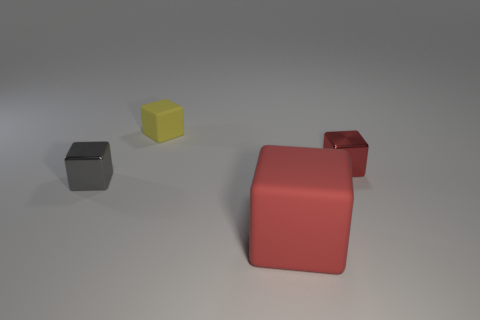How big is the gray object behind the red object that is in front of the tiny metallic block that is right of the gray thing?
Offer a terse response. Small. Is the tiny red shiny object the same shape as the big red thing?
Provide a succinct answer. Yes. There is a object that is both to the right of the yellow thing and behind the red matte block; how big is it?
Provide a succinct answer. Small. There is a tiny red thing that is the same shape as the tiny yellow thing; what material is it?
Your response must be concise. Metal. What is the material of the red thing to the right of the red thing that is in front of the tiny gray thing?
Ensure brevity in your answer.  Metal. There is a yellow matte object; does it have the same shape as the red thing that is right of the red matte object?
Your answer should be very brief. Yes. What number of rubber objects are big things or cyan balls?
Ensure brevity in your answer.  1. The metallic object on the left side of the shiny cube behind the tiny metallic thing that is left of the small matte block is what color?
Keep it short and to the point. Gray. How many other objects are the same material as the tiny gray object?
Provide a short and direct response. 1. There is a matte object that is behind the big matte object; is its shape the same as the red rubber object?
Your answer should be compact. Yes. 